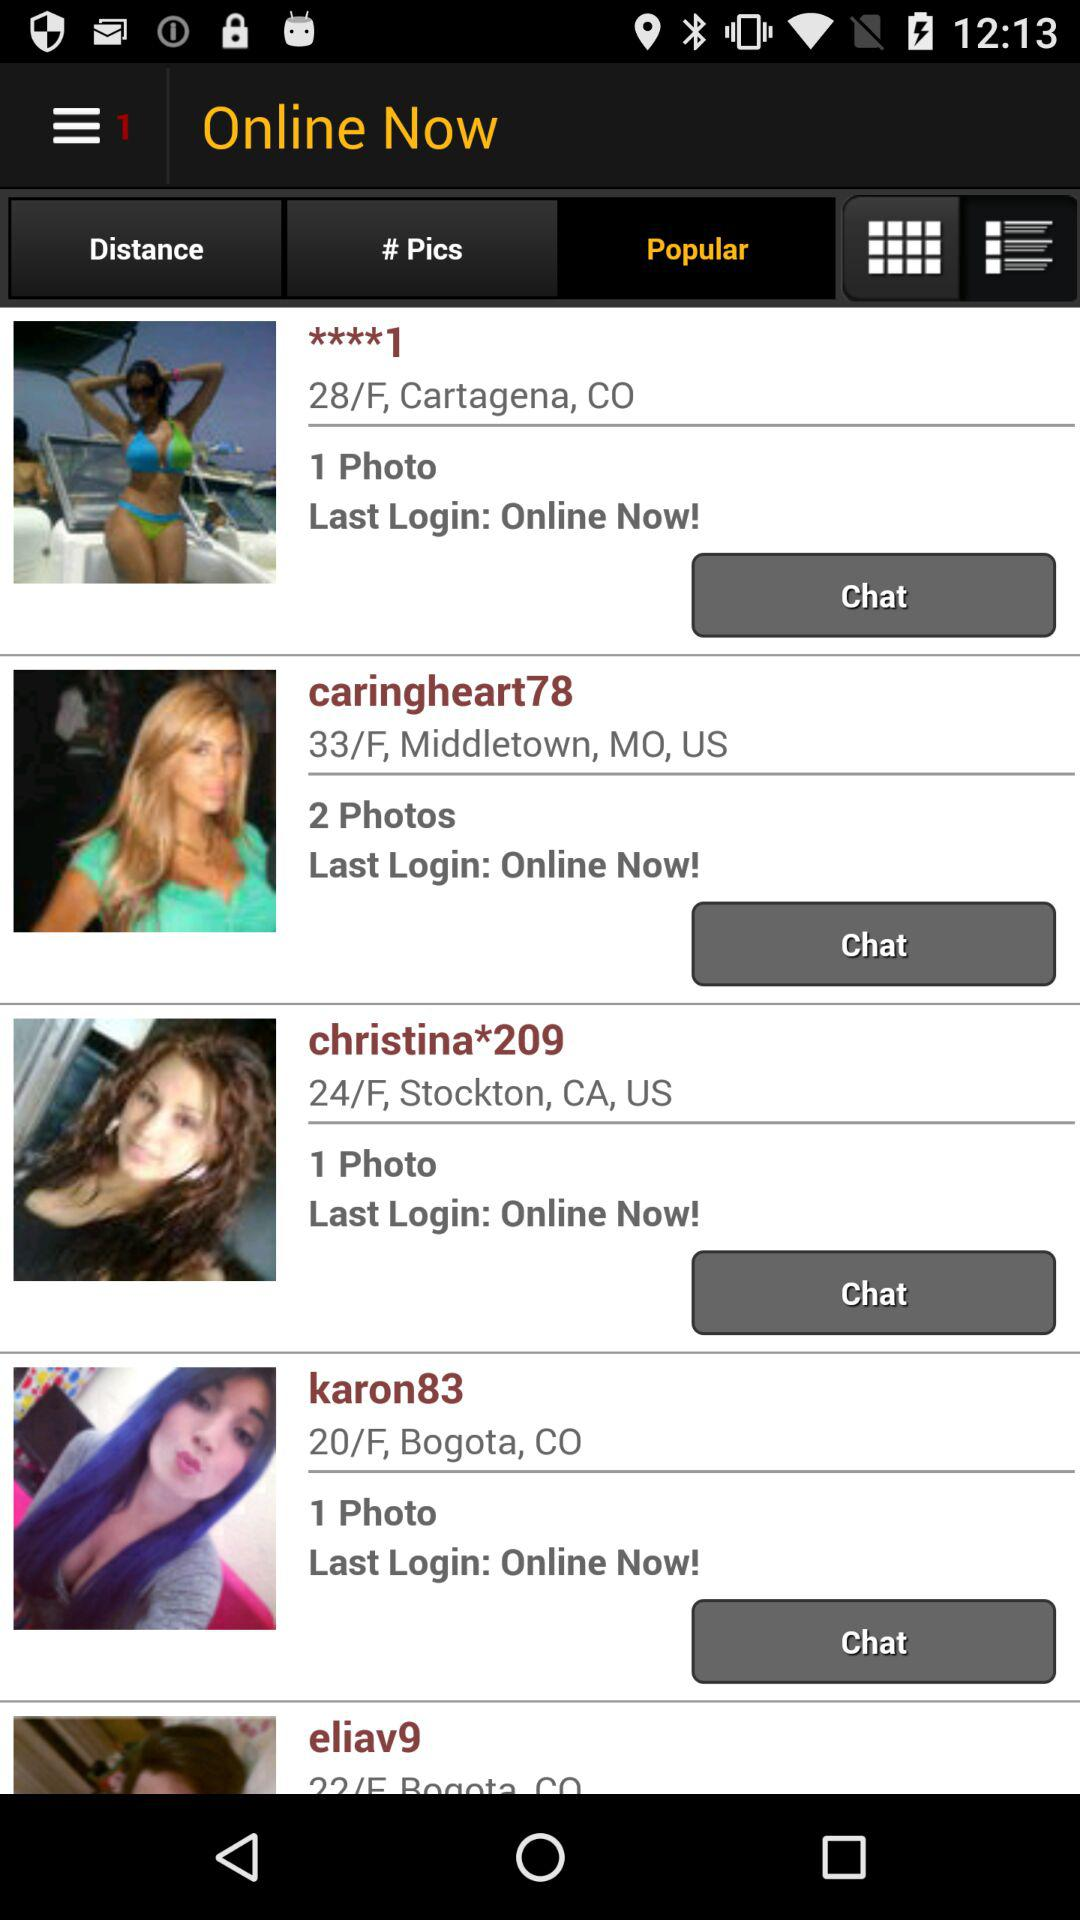How old is "caringheart78"? "caringheart78" is 33 years old. 